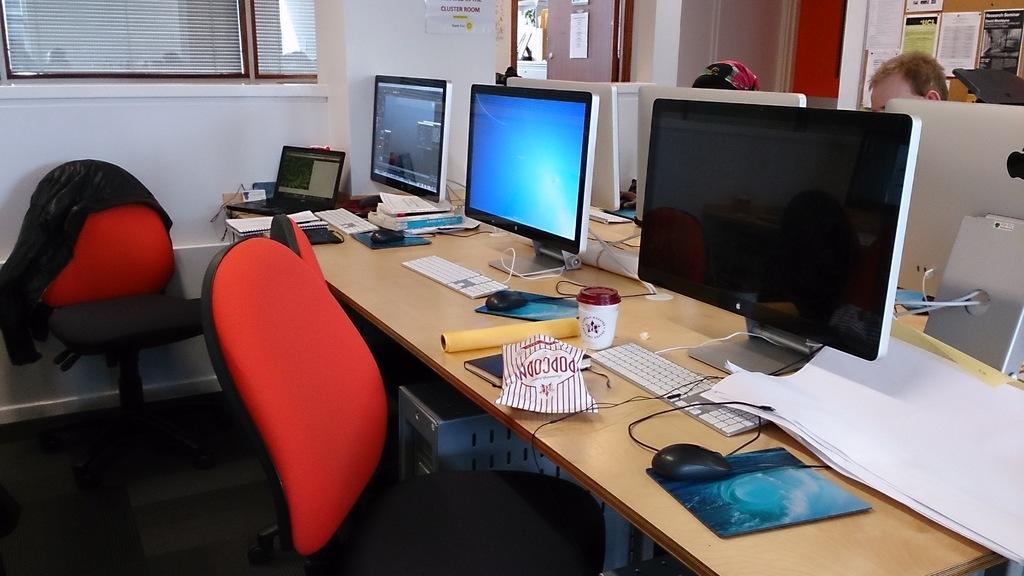Is that a bag of popcorn?
Offer a terse response. Yes. 